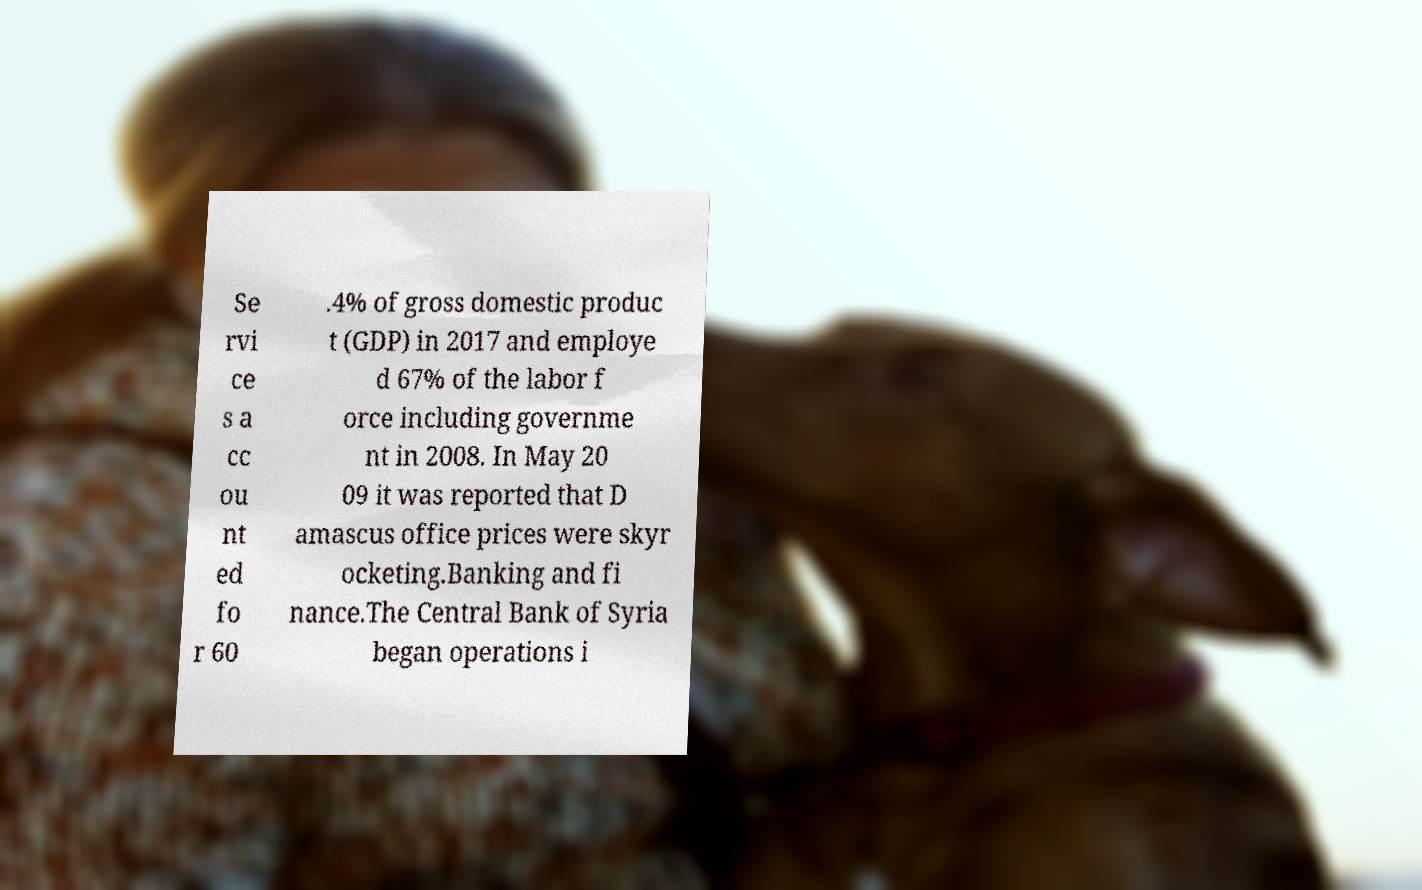I need the written content from this picture converted into text. Can you do that? Se rvi ce s a cc ou nt ed fo r 60 .4% of gross domestic produc t (GDP) in 2017 and employe d 67% of the labor f orce including governme nt in 2008. In May 20 09 it was reported that D amascus office prices were skyr ocketing.Banking and fi nance.The Central Bank of Syria began operations i 